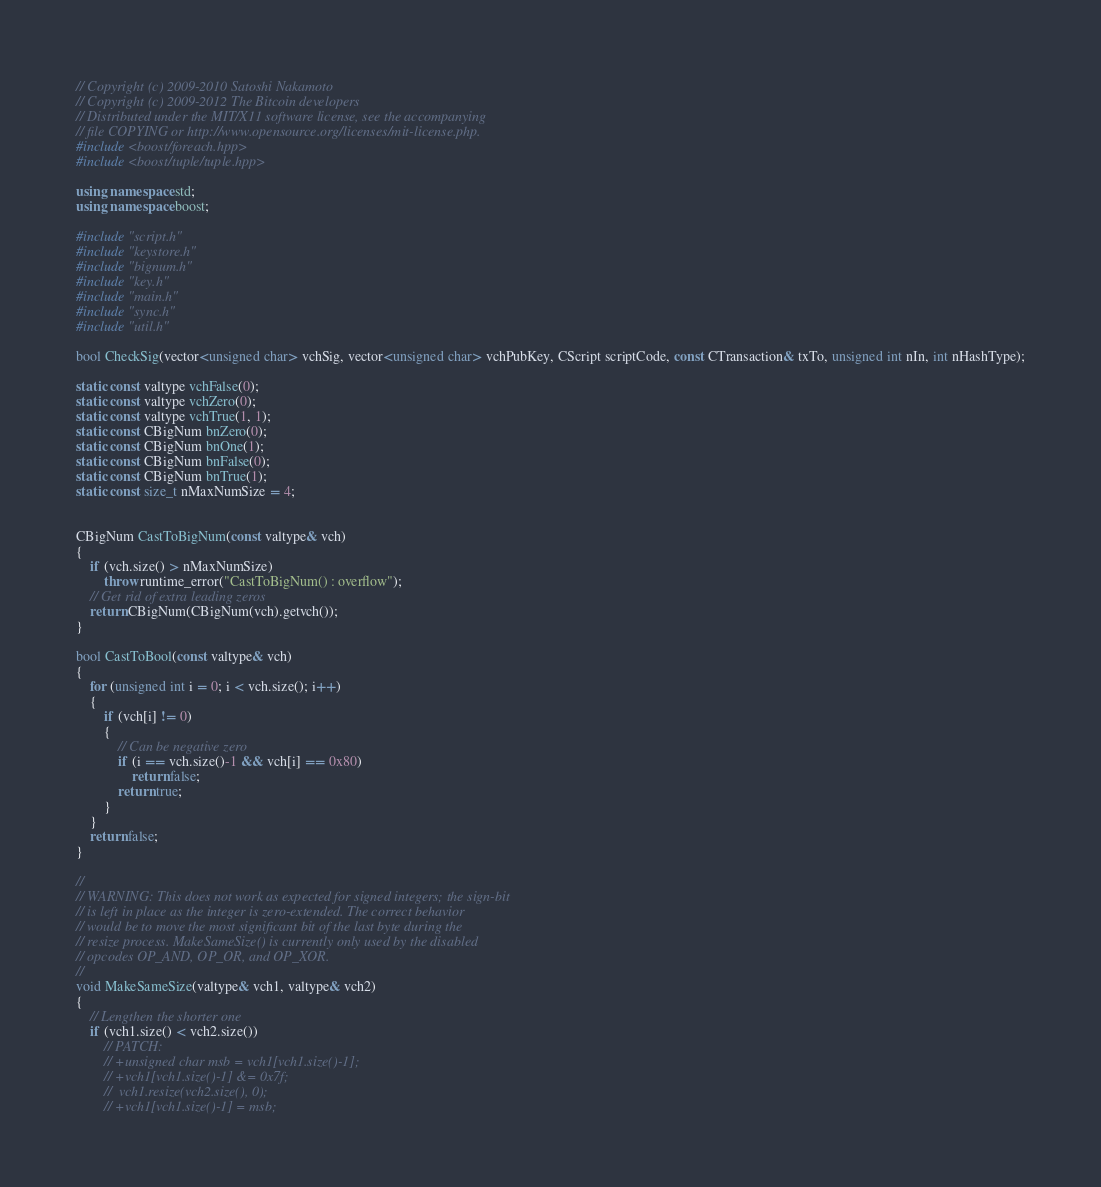<code> <loc_0><loc_0><loc_500><loc_500><_C++_>// Copyright (c) 2009-2010 Satoshi Nakamoto
// Copyright (c) 2009-2012 The Bitcoin developers
// Distributed under the MIT/X11 software license, see the accompanying
// file COPYING or http://www.opensource.org/licenses/mit-license.php.
#include <boost/foreach.hpp>
#include <boost/tuple/tuple.hpp>

using namespace std;
using namespace boost;

#include "script.h"
#include "keystore.h"
#include "bignum.h"
#include "key.h"
#include "main.h"
#include "sync.h"
#include "util.h"

bool CheckSig(vector<unsigned char> vchSig, vector<unsigned char> vchPubKey, CScript scriptCode, const CTransaction& txTo, unsigned int nIn, int nHashType);

static const valtype vchFalse(0);
static const valtype vchZero(0);
static const valtype vchTrue(1, 1);
static const CBigNum bnZero(0);
static const CBigNum bnOne(1);
static const CBigNum bnFalse(0);
static const CBigNum bnTrue(1);
static const size_t nMaxNumSize = 4;


CBigNum CastToBigNum(const valtype& vch)
{
    if (vch.size() > nMaxNumSize)
        throw runtime_error("CastToBigNum() : overflow");
    // Get rid of extra leading zeros
    return CBigNum(CBigNum(vch).getvch());
}

bool CastToBool(const valtype& vch)
{
    for (unsigned int i = 0; i < vch.size(); i++)
    {
        if (vch[i] != 0)
        {
            // Can be negative zero
            if (i == vch.size()-1 && vch[i] == 0x80)
                return false;
            return true;
        }
    }
    return false;
}

//
// WARNING: This does not work as expected for signed integers; the sign-bit
// is left in place as the integer is zero-extended. The correct behavior
// would be to move the most significant bit of the last byte during the
// resize process. MakeSameSize() is currently only used by the disabled
// opcodes OP_AND, OP_OR, and OP_XOR.
//
void MakeSameSize(valtype& vch1, valtype& vch2)
{
    // Lengthen the shorter one
    if (vch1.size() < vch2.size())
        // PATCH:
        // +unsigned char msb = vch1[vch1.size()-1];
        // +vch1[vch1.size()-1] &= 0x7f;
        //  vch1.resize(vch2.size(), 0);
        // +vch1[vch1.size()-1] = msb;</code> 